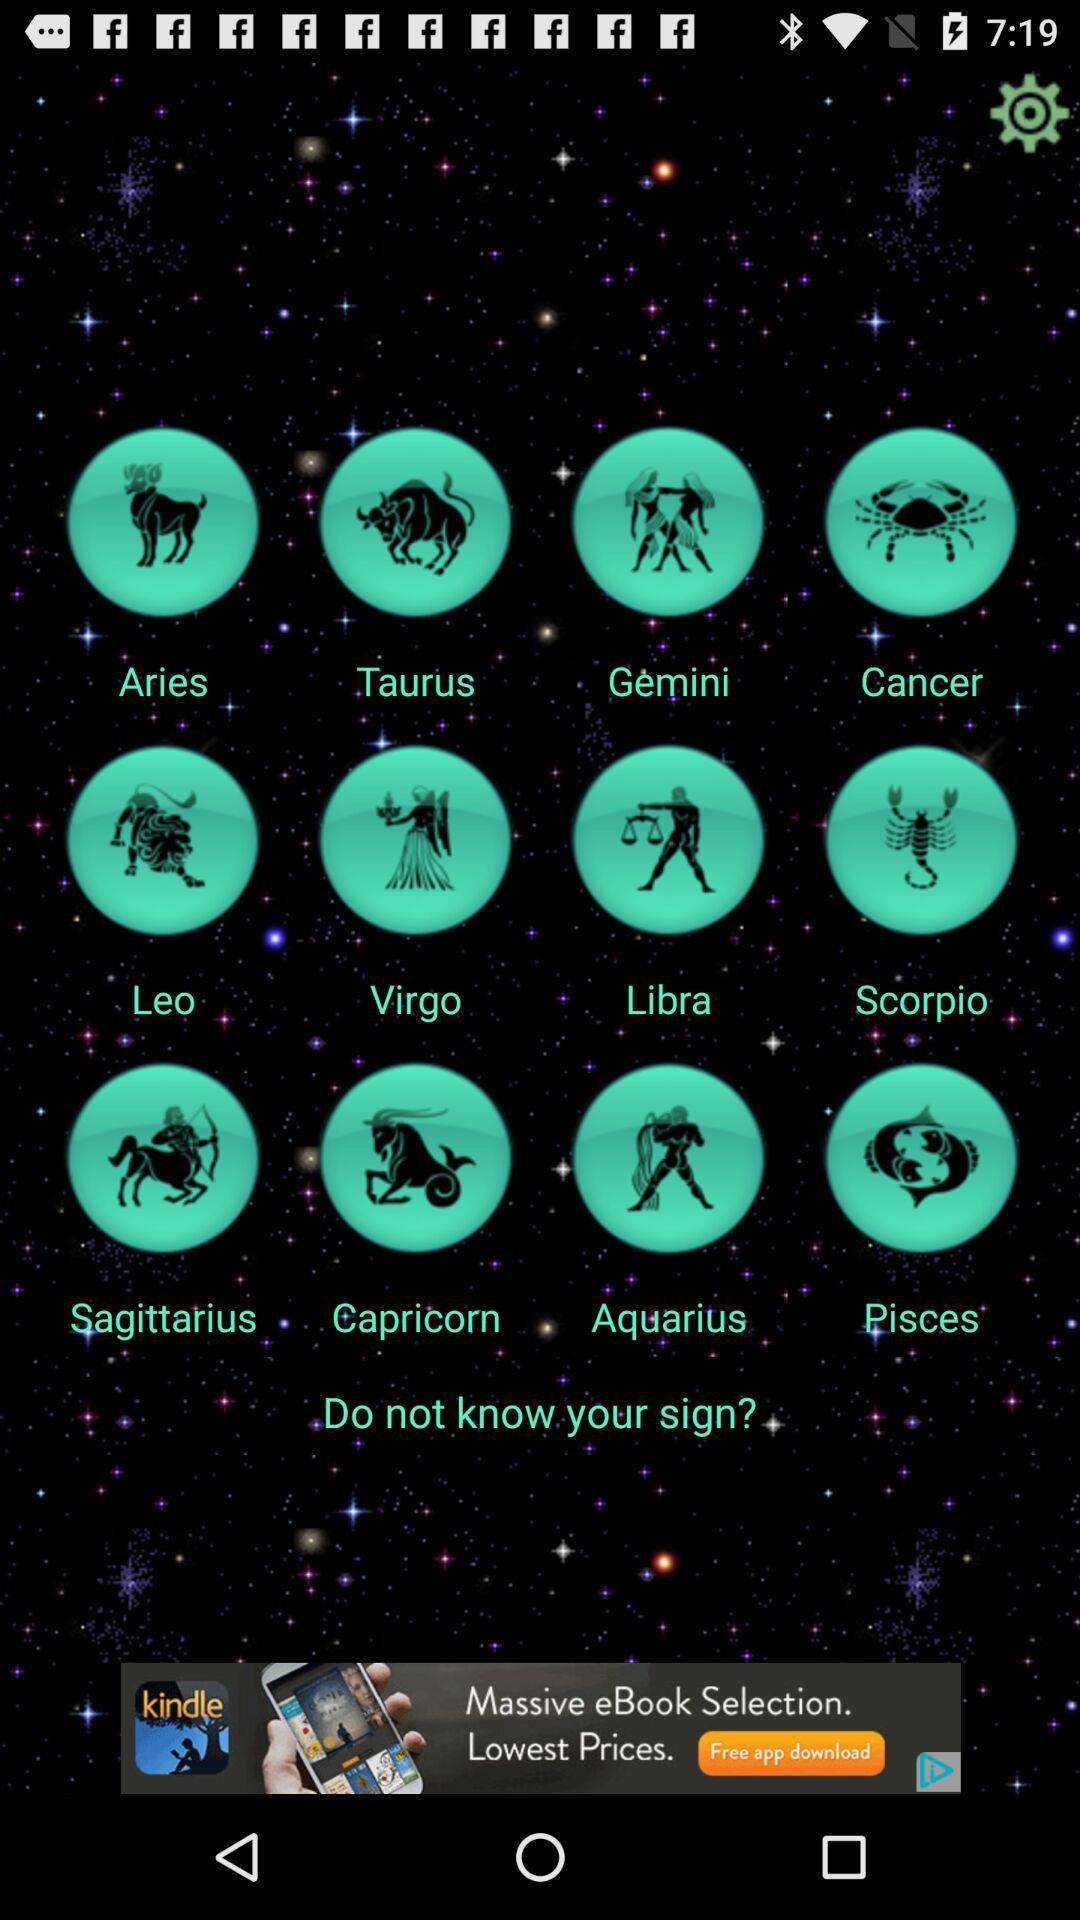How many signs are there in total?
Answer the question using a single word or phrase. 12 